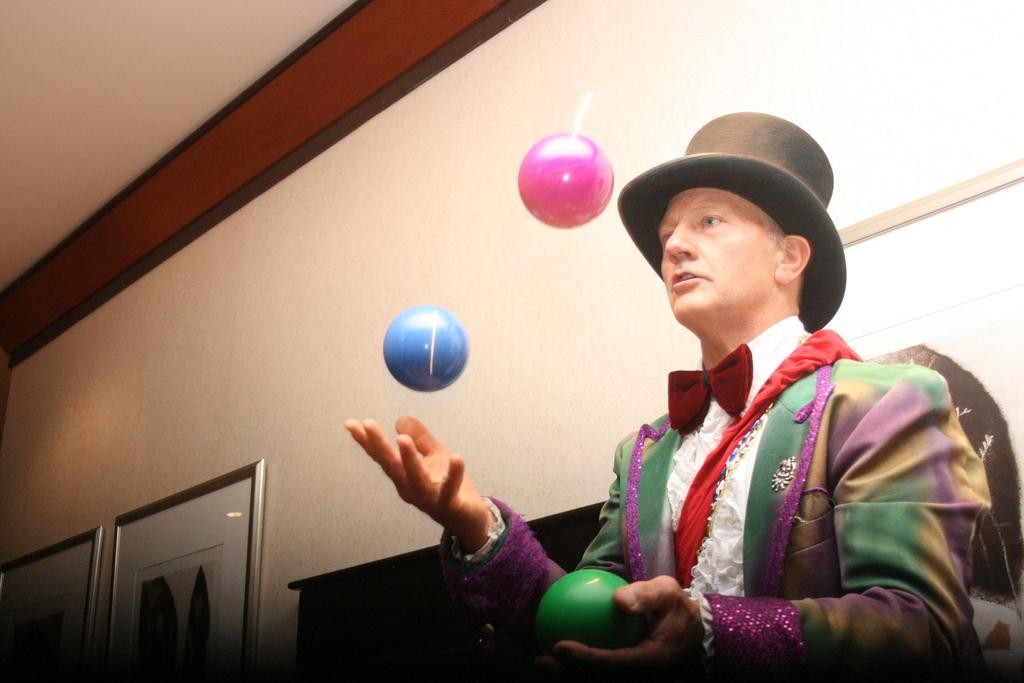Please provide a concise description of this image. In this image I can see a person holding a ball and wearing a cap and I can see two balls visible in the air in front of the person and I can see the wall in the middle I can see photo frames attached to the wall. 